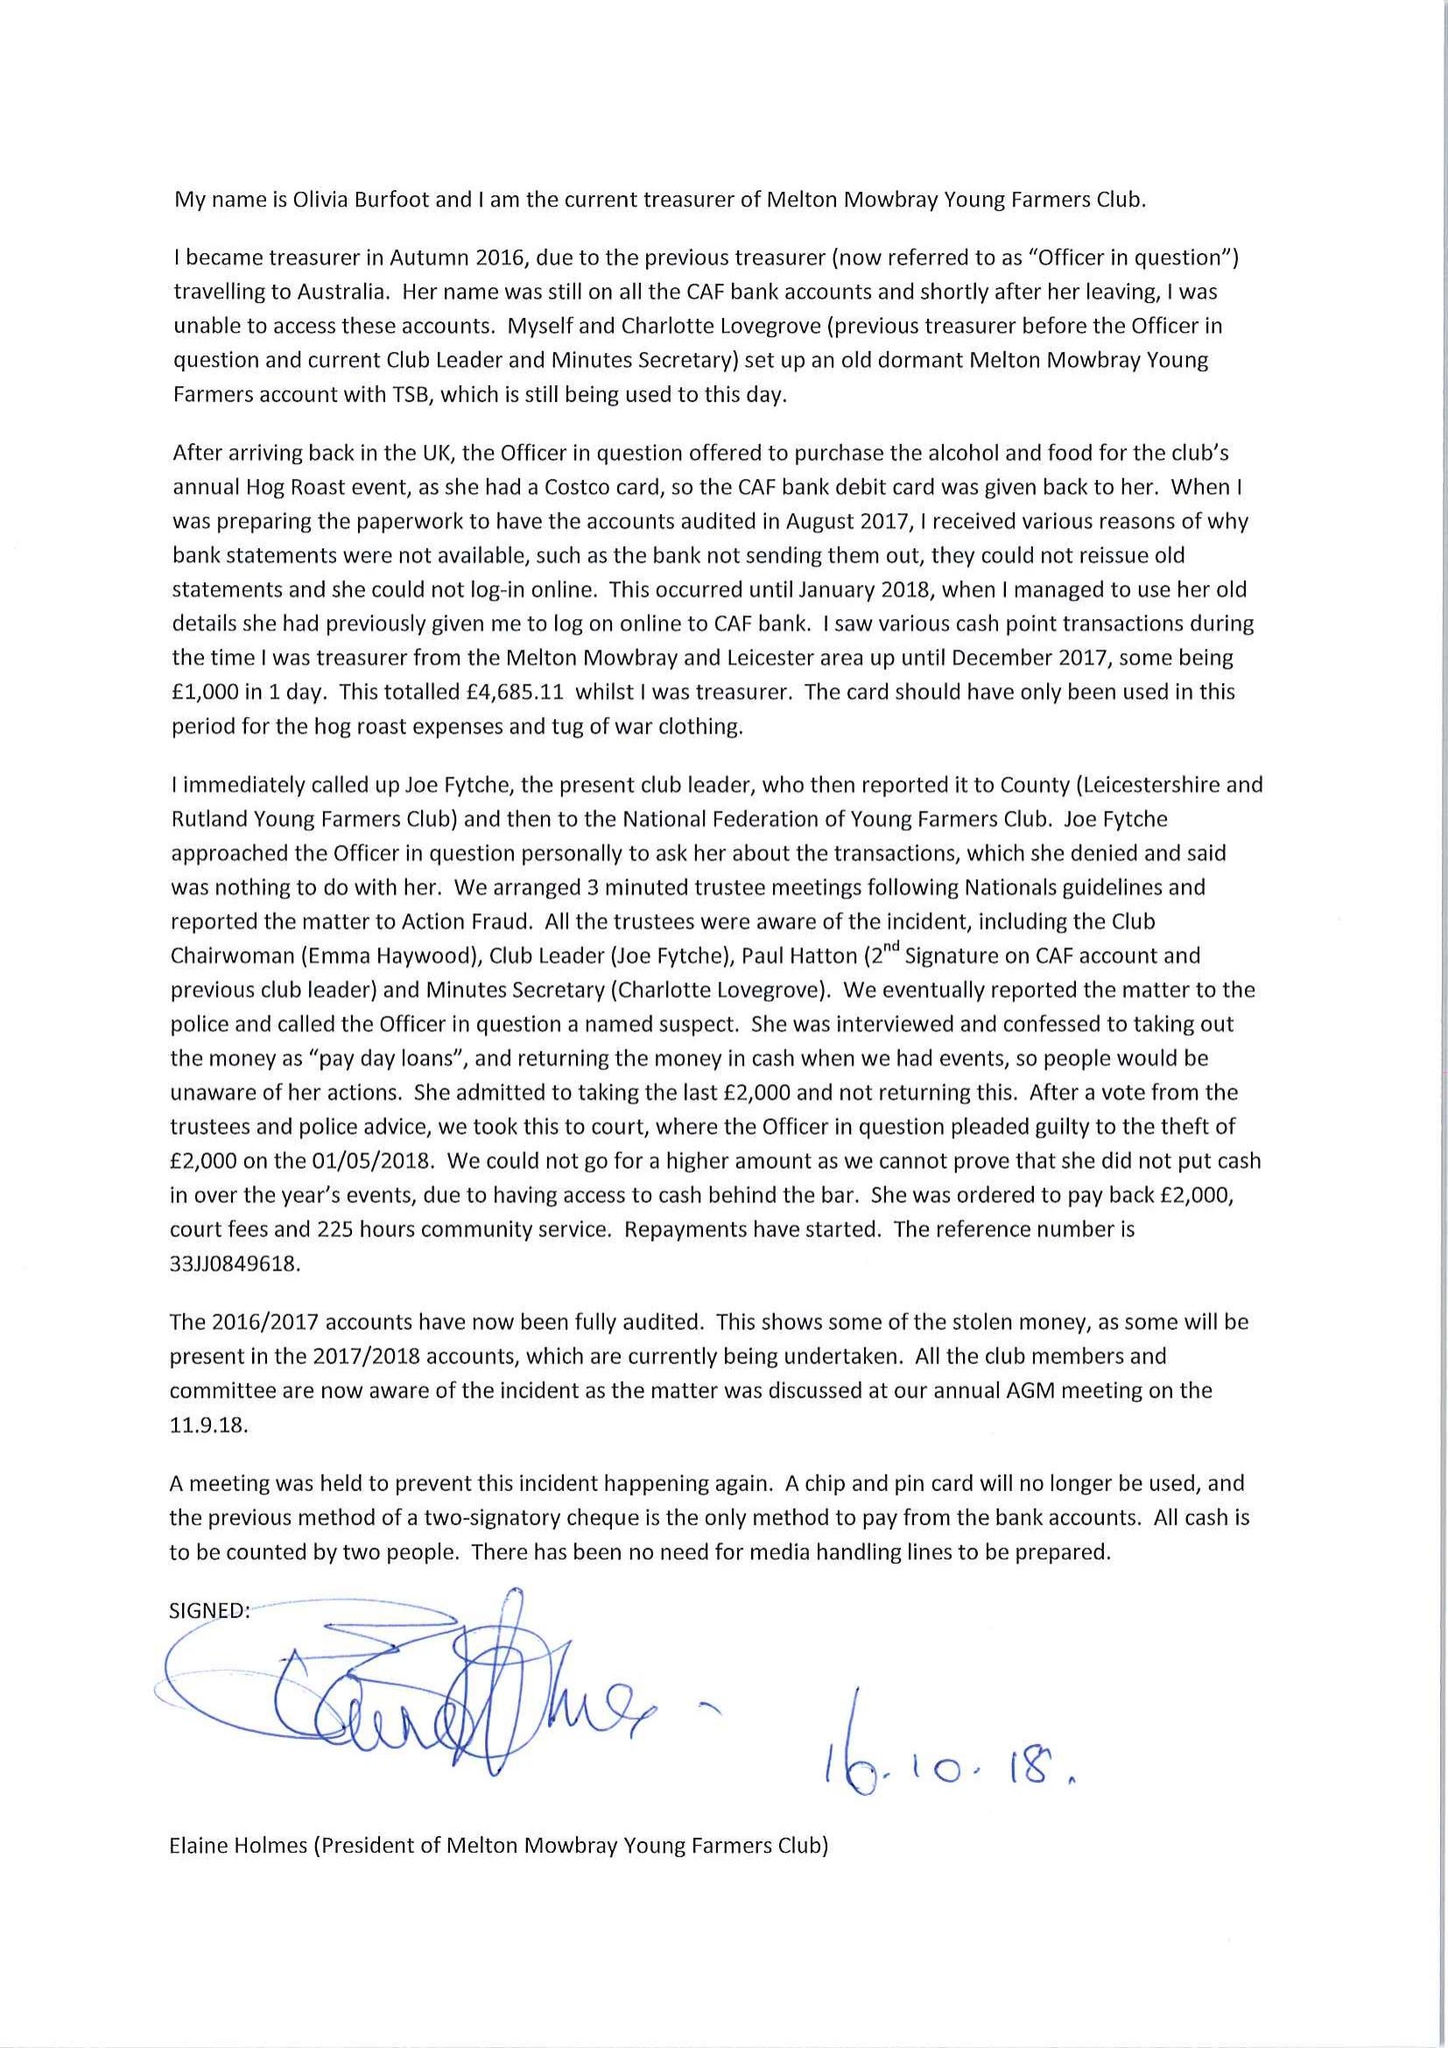What is the value for the charity_number?
Answer the question using a single word or phrase. 508696 